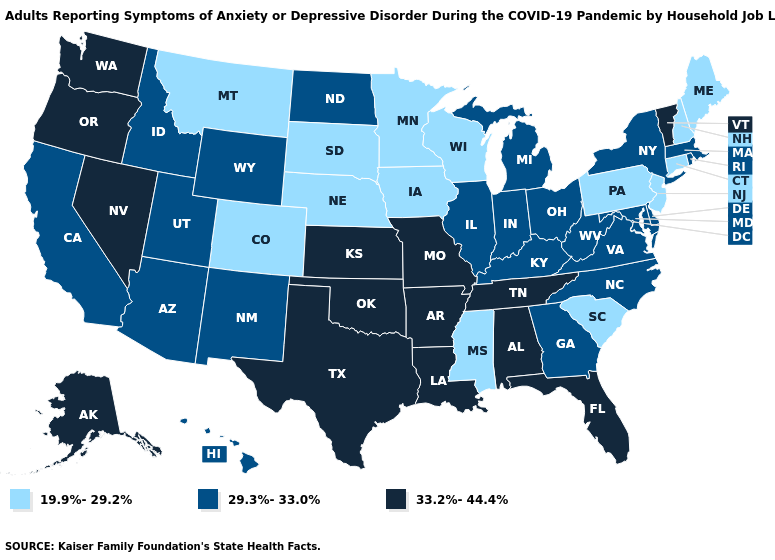What is the value of New York?
Write a very short answer. 29.3%-33.0%. What is the value of Minnesota?
Answer briefly. 19.9%-29.2%. What is the lowest value in the West?
Short answer required. 19.9%-29.2%. Name the states that have a value in the range 19.9%-29.2%?
Write a very short answer. Colorado, Connecticut, Iowa, Maine, Minnesota, Mississippi, Montana, Nebraska, New Hampshire, New Jersey, Pennsylvania, South Carolina, South Dakota, Wisconsin. What is the lowest value in the West?
Be succinct. 19.9%-29.2%. What is the value of Ohio?
Concise answer only. 29.3%-33.0%. What is the highest value in the USA?
Short answer required. 33.2%-44.4%. Does South Carolina have the lowest value in the South?
Concise answer only. Yes. Does Colorado have the lowest value in the West?
Quick response, please. Yes. Does Maryland have the lowest value in the South?
Be succinct. No. What is the highest value in the South ?
Answer briefly. 33.2%-44.4%. Name the states that have a value in the range 33.2%-44.4%?
Short answer required. Alabama, Alaska, Arkansas, Florida, Kansas, Louisiana, Missouri, Nevada, Oklahoma, Oregon, Tennessee, Texas, Vermont, Washington. Does the map have missing data?
Answer briefly. No. Name the states that have a value in the range 19.9%-29.2%?
Short answer required. Colorado, Connecticut, Iowa, Maine, Minnesota, Mississippi, Montana, Nebraska, New Hampshire, New Jersey, Pennsylvania, South Carolina, South Dakota, Wisconsin. 